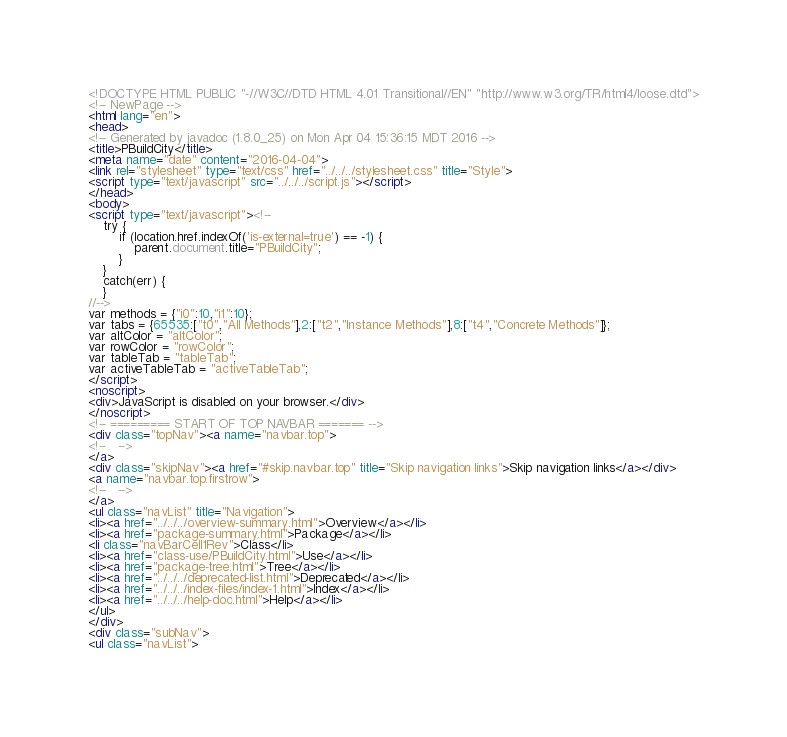Convert code to text. <code><loc_0><loc_0><loc_500><loc_500><_HTML_><!DOCTYPE HTML PUBLIC "-//W3C//DTD HTML 4.01 Transitional//EN" "http://www.w3.org/TR/html4/loose.dtd">
<!-- NewPage -->
<html lang="en">
<head>
<!-- Generated by javadoc (1.8.0_25) on Mon Apr 04 15:36:15 MDT 2016 -->
<title>PBuildCity</title>
<meta name="date" content="2016-04-04">
<link rel="stylesheet" type="text/css" href="../../../stylesheet.css" title="Style">
<script type="text/javascript" src="../../../script.js"></script>
</head>
<body>
<script type="text/javascript"><!--
    try {
        if (location.href.indexOf('is-external=true') == -1) {
            parent.document.title="PBuildCity";
        }
    }
    catch(err) {
    }
//-->
var methods = {"i0":10,"i1":10};
var tabs = {65535:["t0","All Methods"],2:["t2","Instance Methods"],8:["t4","Concrete Methods"]};
var altColor = "altColor";
var rowColor = "rowColor";
var tableTab = "tableTab";
var activeTableTab = "activeTableTab";
</script>
<noscript>
<div>JavaScript is disabled on your browser.</div>
</noscript>
<!-- ========= START OF TOP NAVBAR ======= -->
<div class="topNav"><a name="navbar.top">
<!--   -->
</a>
<div class="skipNav"><a href="#skip.navbar.top" title="Skip navigation links">Skip navigation links</a></div>
<a name="navbar.top.firstrow">
<!--   -->
</a>
<ul class="navList" title="Navigation">
<li><a href="../../../overview-summary.html">Overview</a></li>
<li><a href="package-summary.html">Package</a></li>
<li class="navBarCell1Rev">Class</li>
<li><a href="class-use/PBuildCity.html">Use</a></li>
<li><a href="package-tree.html">Tree</a></li>
<li><a href="../../../deprecated-list.html">Deprecated</a></li>
<li><a href="../../../index-files/index-1.html">Index</a></li>
<li><a href="../../../help-doc.html">Help</a></li>
</ul>
</div>
<div class="subNav">
<ul class="navList"></code> 